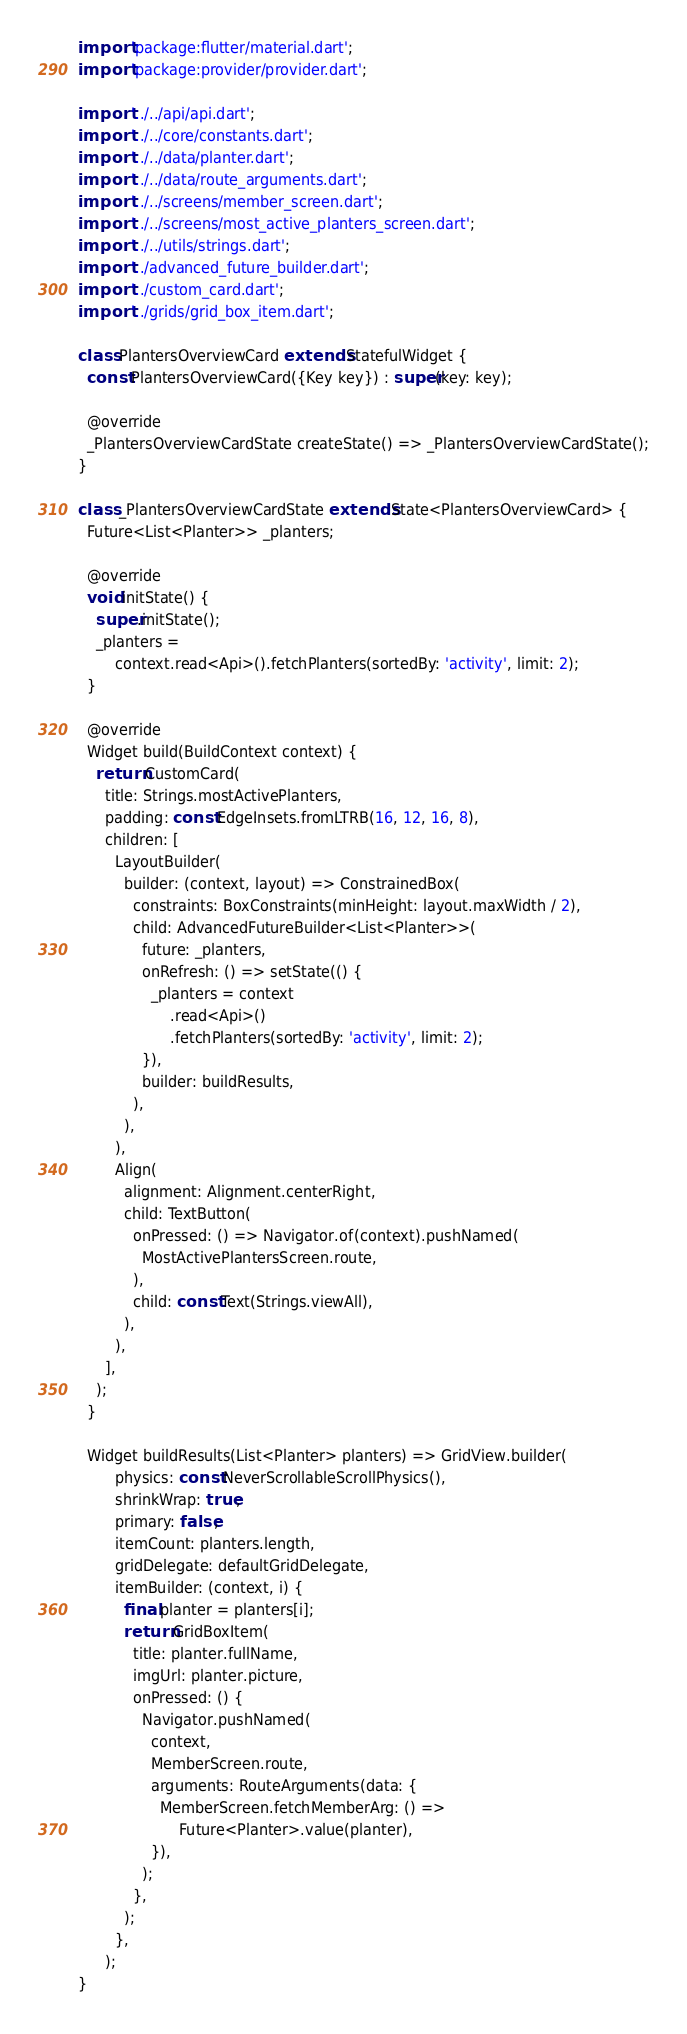Convert code to text. <code><loc_0><loc_0><loc_500><loc_500><_Dart_>import 'package:flutter/material.dart';
import 'package:provider/provider.dart';

import '../../api/api.dart';
import '../../core/constants.dart';
import '../../data/planter.dart';
import '../../data/route_arguments.dart';
import '../../screens/member_screen.dart';
import '../../screens/most_active_planters_screen.dart';
import '../../utils/strings.dart';
import '../advanced_future_builder.dart';
import '../custom_card.dart';
import '../grids/grid_box_item.dart';

class PlantersOverviewCard extends StatefulWidget {
  const PlantersOverviewCard({Key key}) : super(key: key);

  @override
  _PlantersOverviewCardState createState() => _PlantersOverviewCardState();
}

class _PlantersOverviewCardState extends State<PlantersOverviewCard> {
  Future<List<Planter>> _planters;

  @override
  void initState() {
    super.initState();
    _planters =
        context.read<Api>().fetchPlanters(sortedBy: 'activity', limit: 2);
  }

  @override
  Widget build(BuildContext context) {
    return CustomCard(
      title: Strings.mostActivePlanters,
      padding: const EdgeInsets.fromLTRB(16, 12, 16, 8),
      children: [
        LayoutBuilder(
          builder: (context, layout) => ConstrainedBox(
            constraints: BoxConstraints(minHeight: layout.maxWidth / 2),
            child: AdvancedFutureBuilder<List<Planter>>(
              future: _planters,
              onRefresh: () => setState(() {
                _planters = context
                    .read<Api>()
                    .fetchPlanters(sortedBy: 'activity', limit: 2);
              }),
              builder: buildResults,
            ),
          ),
        ),
        Align(
          alignment: Alignment.centerRight,
          child: TextButton(
            onPressed: () => Navigator.of(context).pushNamed(
              MostActivePlantersScreen.route,
            ),
            child: const Text(Strings.viewAll),
          ),
        ),
      ],
    );
  }

  Widget buildResults(List<Planter> planters) => GridView.builder(
        physics: const NeverScrollableScrollPhysics(),
        shrinkWrap: true,
        primary: false,
        itemCount: planters.length,
        gridDelegate: defaultGridDelegate,
        itemBuilder: (context, i) {
          final planter = planters[i];
          return GridBoxItem(
            title: planter.fullName,
            imgUrl: planter.picture,
            onPressed: () {
              Navigator.pushNamed(
                context,
                MemberScreen.route,
                arguments: RouteArguments(data: {
                  MemberScreen.fetchMemberArg: () =>
                      Future<Planter>.value(planter),
                }),
              );
            },
          );
        },
      );
}
</code> 